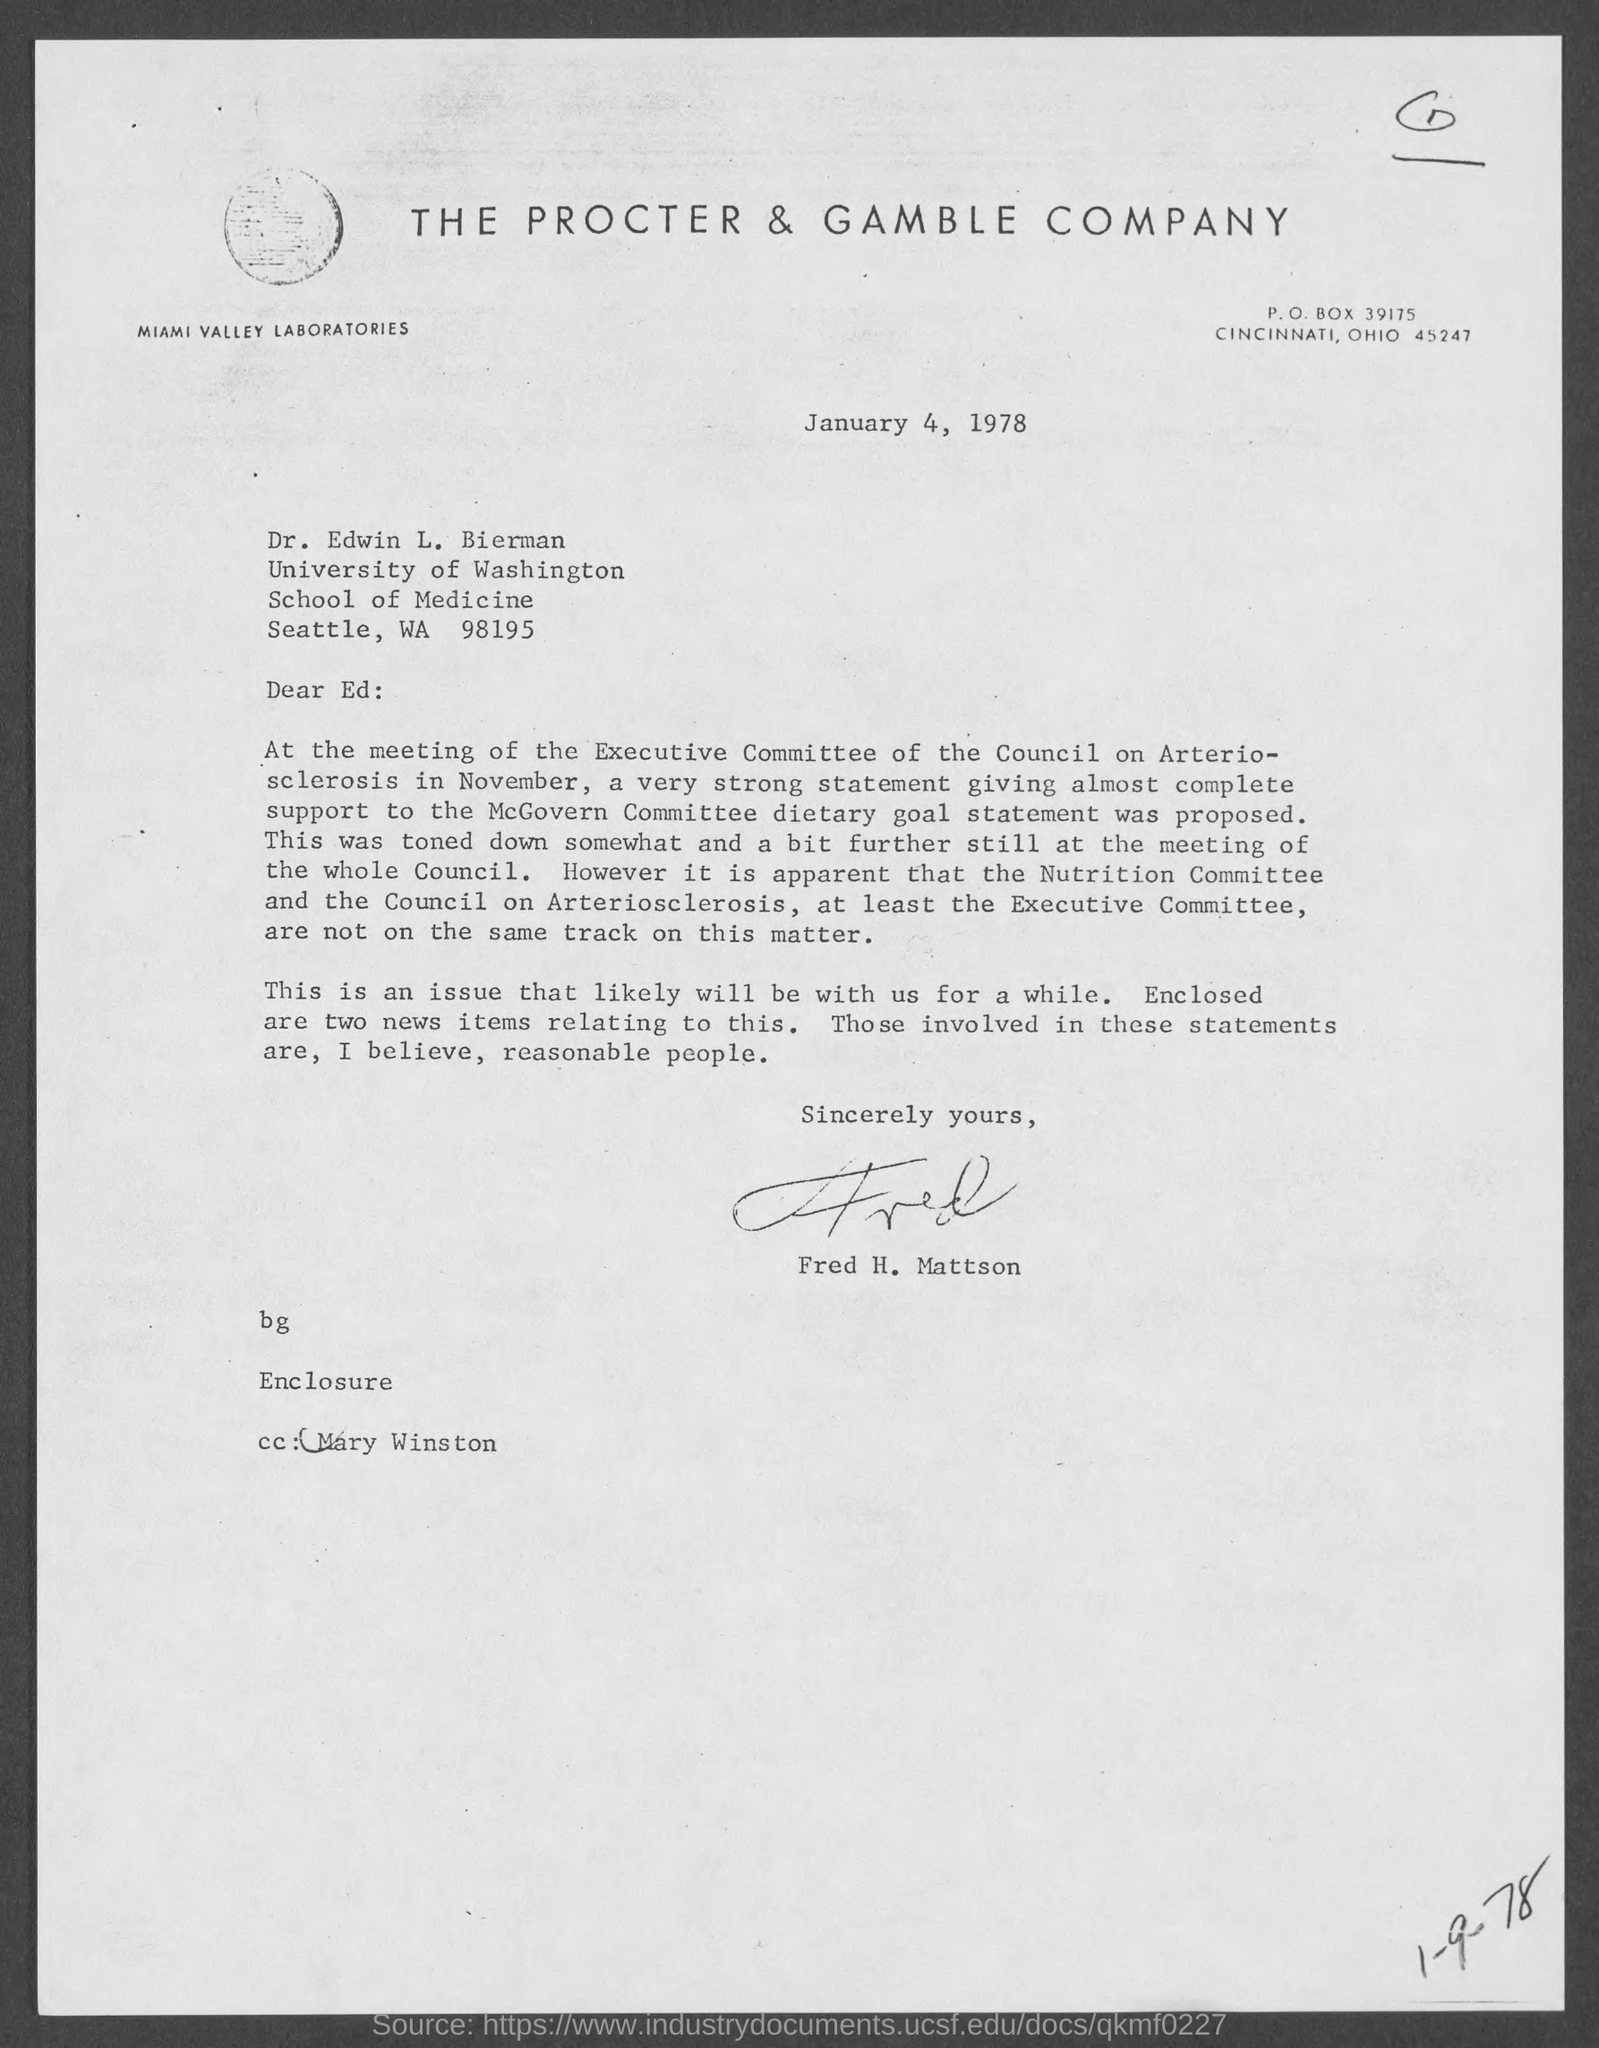List a handful of essential elements in this visual. The letter has been signed by Fred H. Mattson. The identity of the person mentioned in the covering letter is Mary Winston. The issued date of this letter is January 4, 1978. The Procter & Gamble Company is mentioned in the letterhead. 